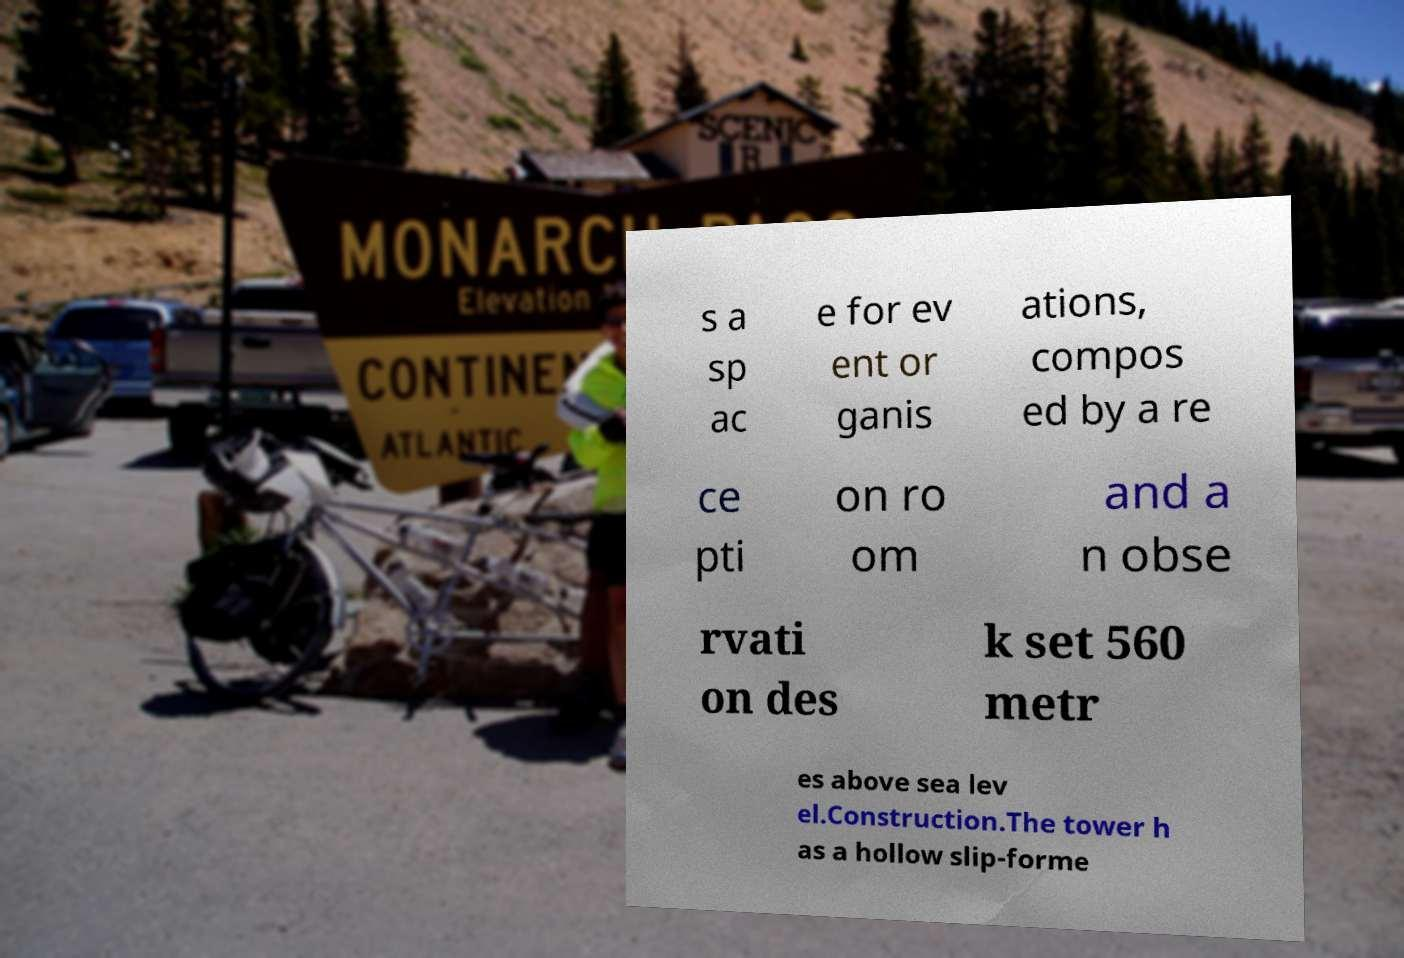Please identify and transcribe the text found in this image. s a sp ac e for ev ent or ganis ations, compos ed by a re ce pti on ro om and a n obse rvati on des k set 560 metr es above sea lev el.Construction.The tower h as a hollow slip-forme 